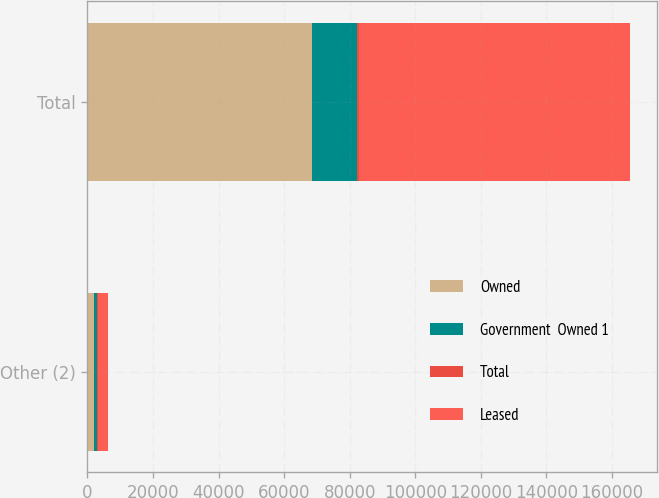Convert chart to OTSL. <chart><loc_0><loc_0><loc_500><loc_500><stacked_bar_chart><ecel><fcel>Other (2)<fcel>Total<nl><fcel>Owned<fcel>2155<fcel>68421<nl><fcel>Government  Owned 1<fcel>748<fcel>13953<nl><fcel>Total<fcel>318<fcel>318<nl><fcel>Leased<fcel>3221<fcel>82692<nl></chart> 